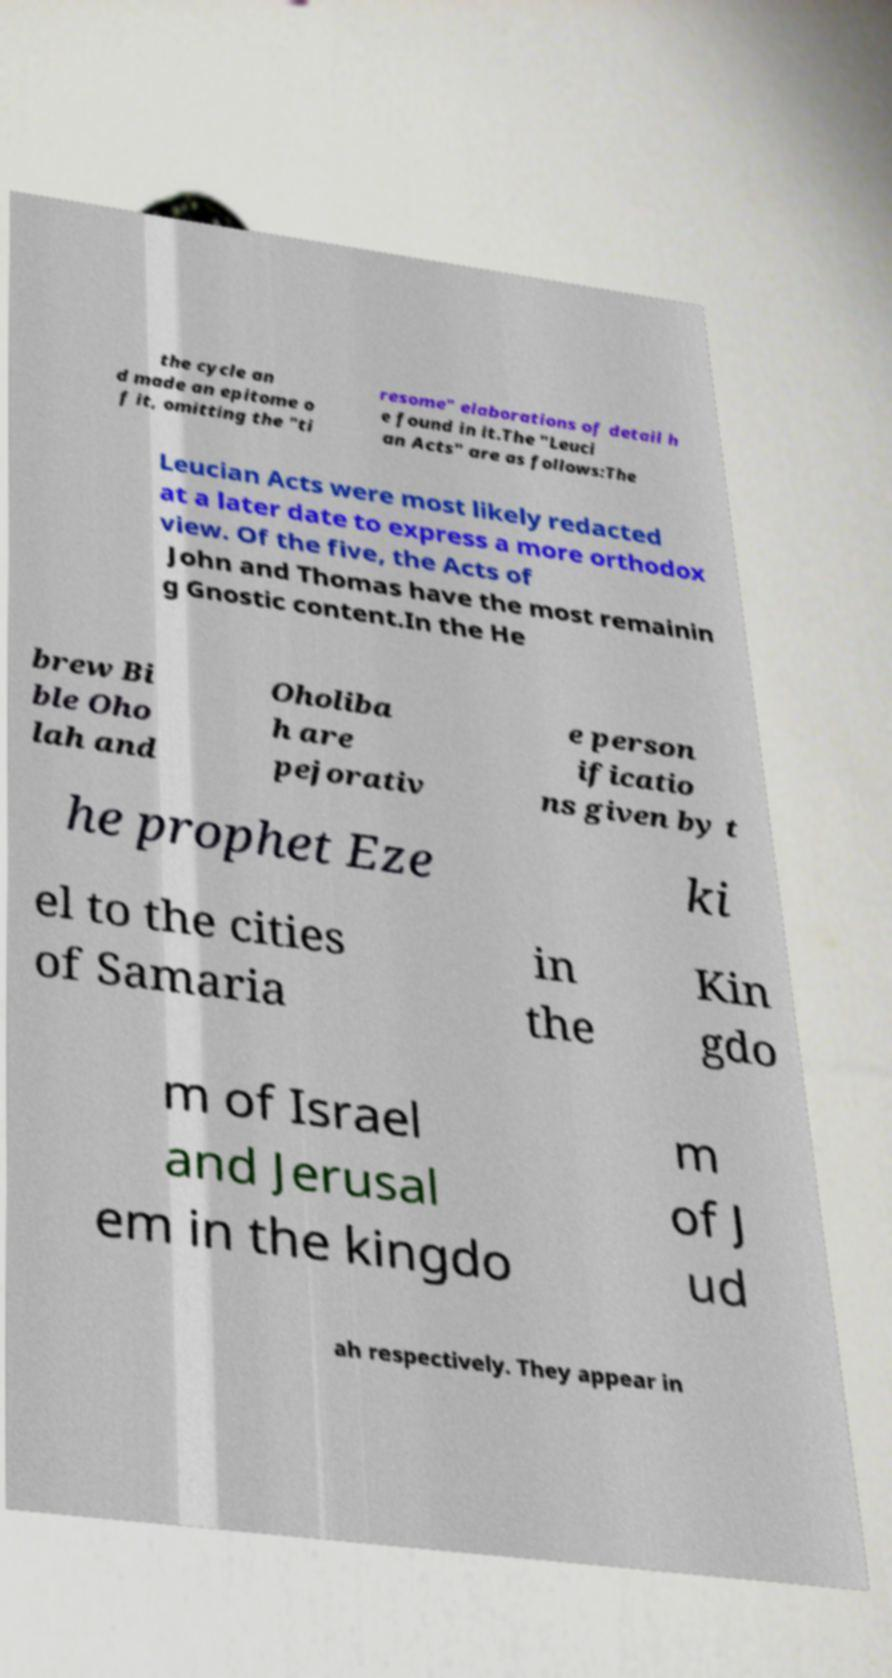Please identify and transcribe the text found in this image. the cycle an d made an epitome o f it, omitting the "ti resome" elaborations of detail h e found in it.The "Leuci an Acts" are as follows:The Leucian Acts were most likely redacted at a later date to express a more orthodox view. Of the five, the Acts of John and Thomas have the most remainin g Gnostic content.In the He brew Bi ble Oho lah and Oholiba h are pejorativ e person ificatio ns given by t he prophet Eze ki el to the cities of Samaria in the Kin gdo m of Israel and Jerusal em in the kingdo m of J ud ah respectively. They appear in 